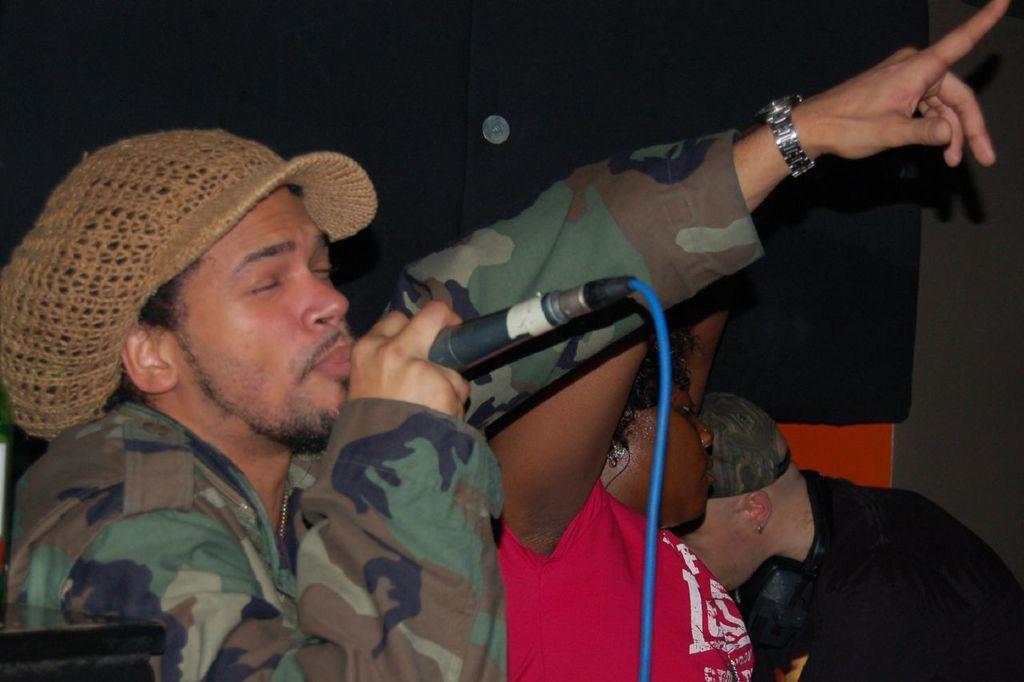Can you describe this image briefly? As we can see in the image there are three people. The man on the left side is holding mic in his hand and singing. 